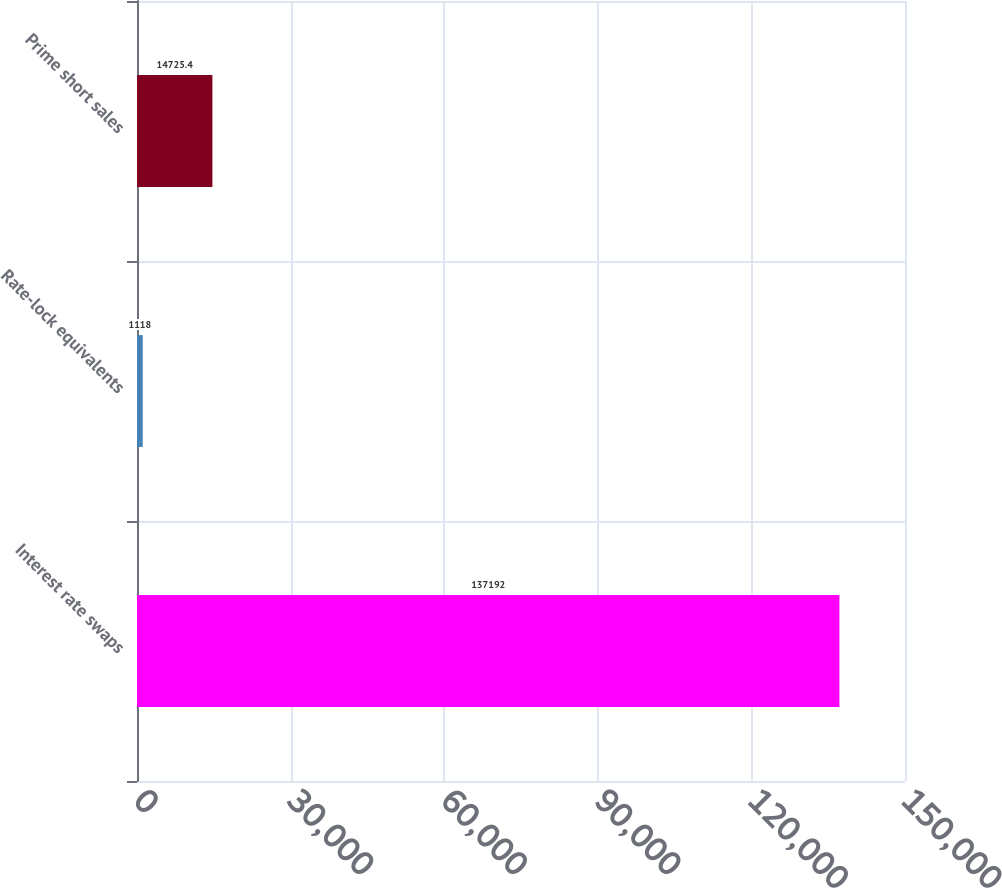Convert chart to OTSL. <chart><loc_0><loc_0><loc_500><loc_500><bar_chart><fcel>Interest rate swaps<fcel>Rate-lock equivalents<fcel>Prime short sales<nl><fcel>137192<fcel>1118<fcel>14725.4<nl></chart> 